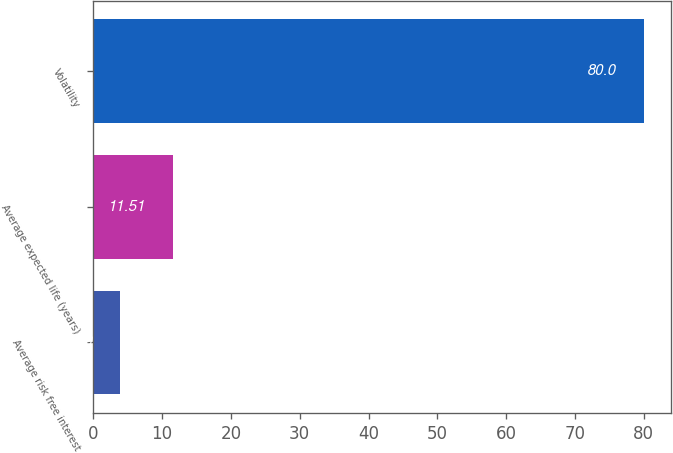Convert chart. <chart><loc_0><loc_0><loc_500><loc_500><bar_chart><fcel>Average risk free interest<fcel>Average expected life (years)<fcel>Volatility<nl><fcel>3.9<fcel>11.51<fcel>80<nl></chart> 